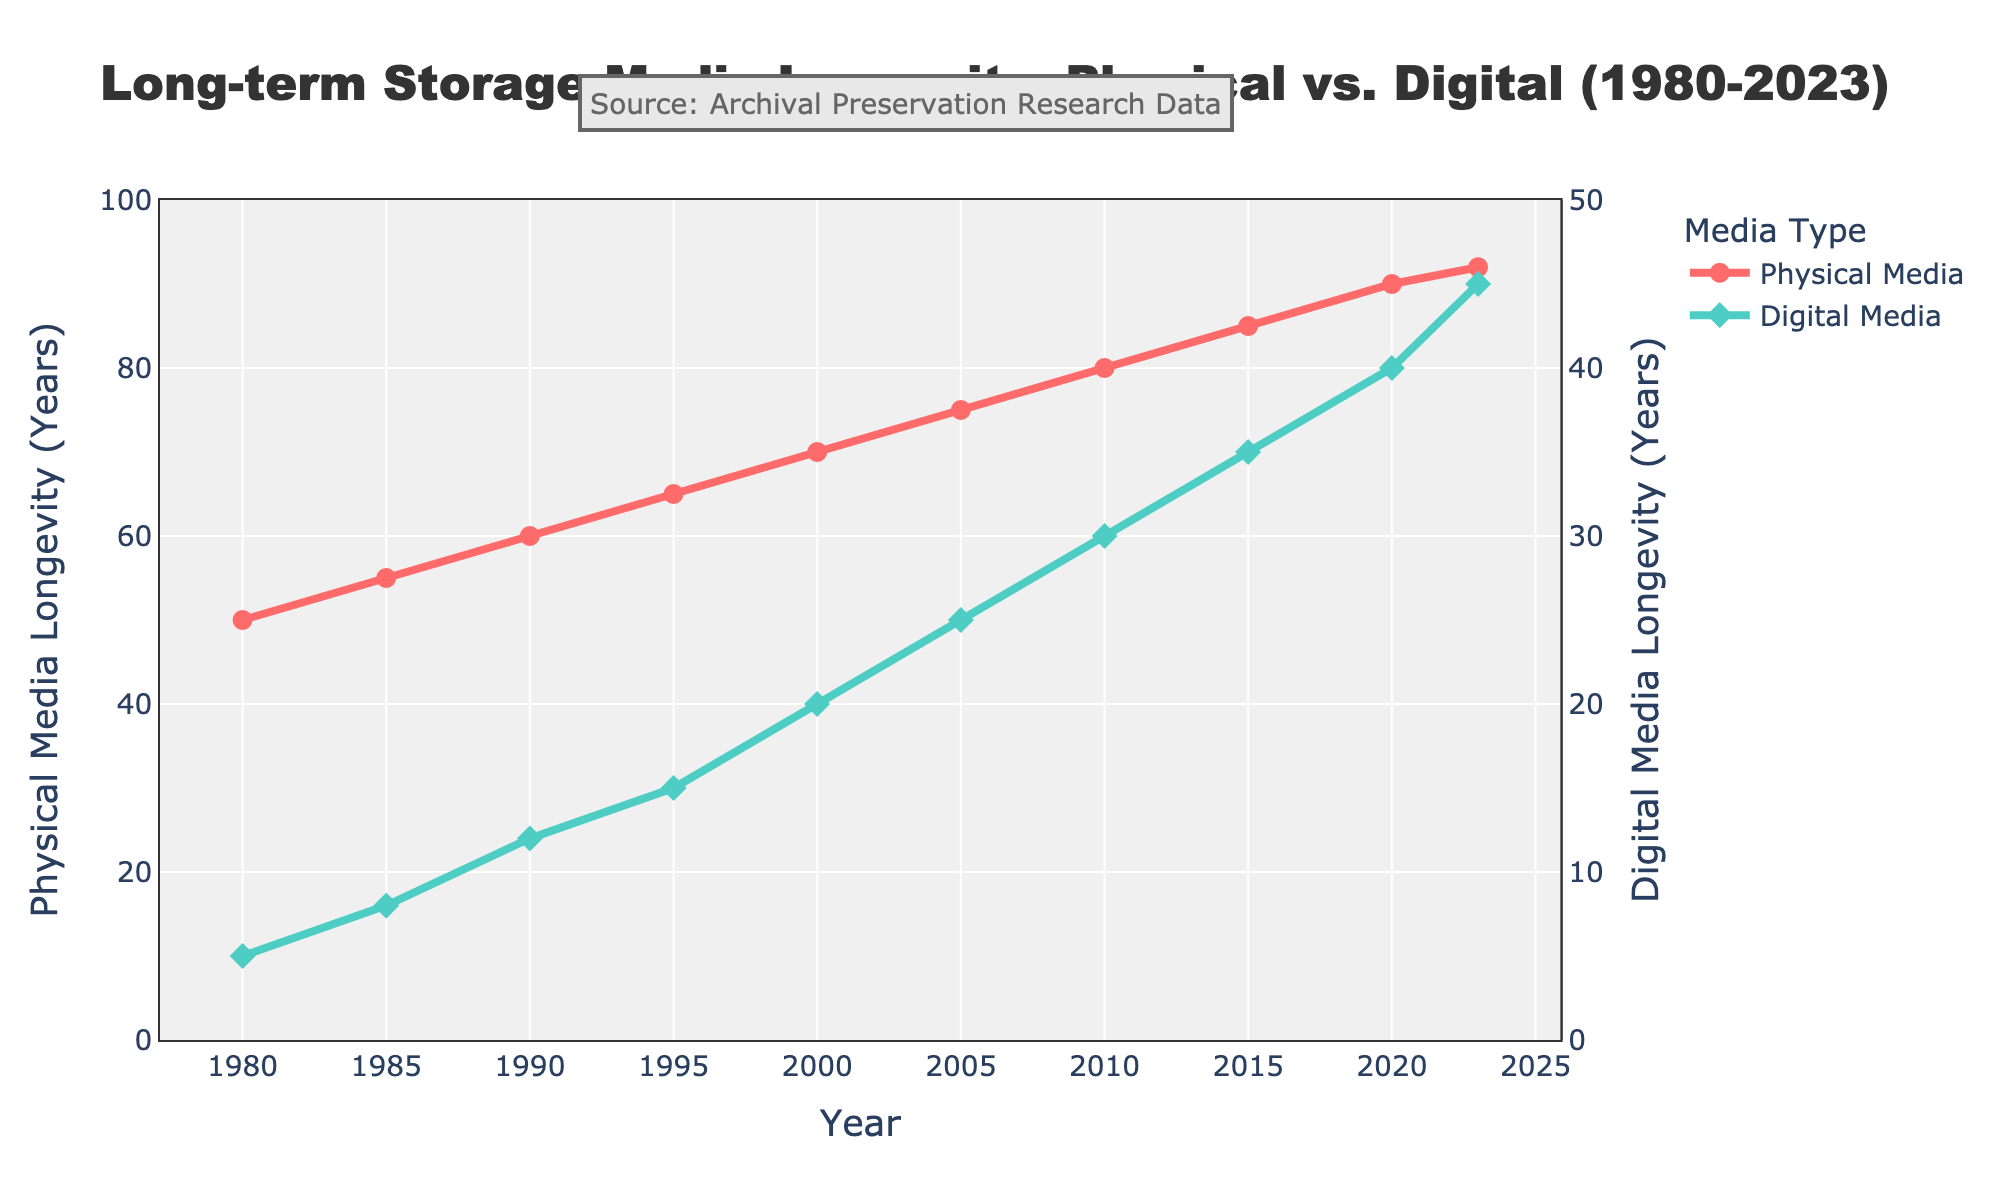What is the difference in longevity between physical media and digital media in 1990? According to the chart, physical media had a longevity of 60 years in 1990, while digital media had a longevity of 12 years. The difference between them is calculated as 60 - 12 = 48 years.
Answer: 48 years How many more years did physical media last compared to digital media in the year 2023? In 2023, the longevity of physical media is 92 years, and for digital media, it is 45 years. The difference is 92 - 45 = 47 years.
Answer: 47 years What is the average longevity of physical media from 1980 to 2023? To calculate the average, sum the longevity of physical media over all years and divide by the number of data points. (50 + 55 + 60 + 65 + 70 + 75 + 80 + 85 + 90 + 92) / 10 = 722 / 10 = 72.2 years.
Answer: 72.2 years During which year was digital media longevity equal to 20 years? The chart shows that digital media had a longevity of 20 years in the year 2000.
Answer: 2000 In which year did physical media reach a longevity of 80 years? The chart shows that physical media reached a longevity of 80 years in the year 2010.
Answer: 2010 By how much did the longevity of digital media increase between 1985 and 2010? In 1985, the longevity of digital media was 8 years, and by 2010, it was 30 years. The increase is calculated as 30 - 8 = 22 years.
Answer: 22 years Which type of media shows a higher growth rate in longevity over the period from 1980 to 2023? To determine the growth rate, we look at the increase in longevity over the entire period for both media types. For physical media: 92 - 50 = 42 years. For digital media: 45 - 5 = 40 years. Physical media shows a slightly higher growth rate.
Answer: Physical media Which data series uses diamond markers on the plot? The chart distinguishes the digital media longevity line with diamond markers.
Answer: Digital media How much did the longevity of physical media increase from 2000 to 2005? In 2000, physical media longevity was 70 years, and in 2005, it was 75 years. The increase is calculated as 75 - 70 = 5 years.
Answer: 5 years What is the median value of digital media longevity from 1980 to 2023? The values for digital media longevity are 5, 8, 12, 15, 20, 25, 30, 35, 40, 45. To find the median, we take the average of the 5th and 6th values: (20 + 25) / 2 = 22.5 years.
Answer: 22.5 years 